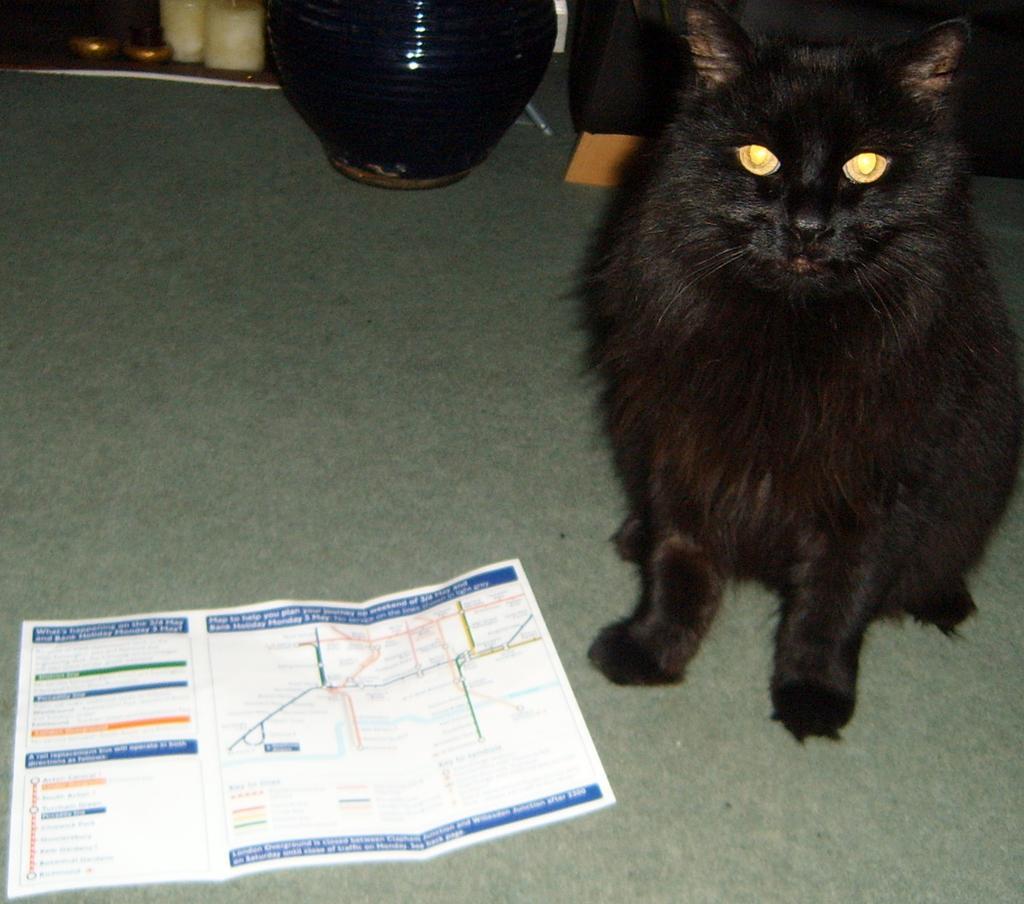In one or two sentences, can you explain what this image depicts? In the image on the floor there is a paper and also there is a black cat sitting on the floor. In the background there is a vase and also there are some other items. 